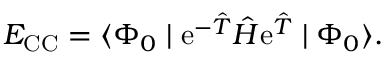Convert formula to latex. <formula><loc_0><loc_0><loc_500><loc_500>E _ { C C } = \langle \Phi _ { 0 } | e ^ { - \hat { T } } \hat { H } e ^ { \hat { T } } | \Phi _ { 0 } \rangle .</formula> 